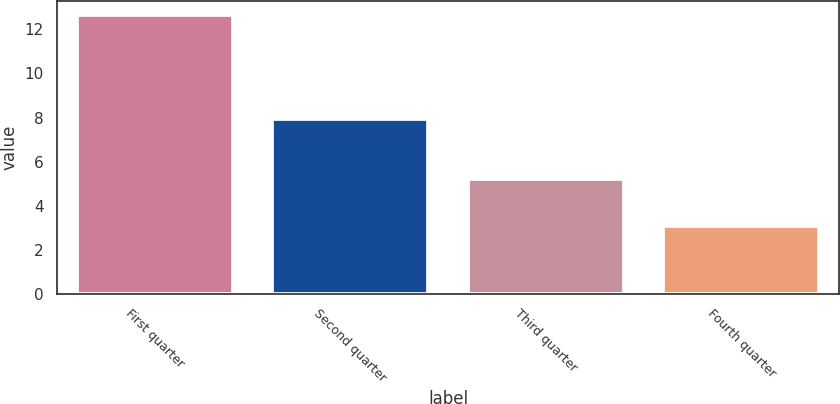Convert chart. <chart><loc_0><loc_0><loc_500><loc_500><bar_chart><fcel>First quarter<fcel>Second quarter<fcel>Third quarter<fcel>Fourth quarter<nl><fcel>12.63<fcel>7.95<fcel>5.2<fcel>3.1<nl></chart> 